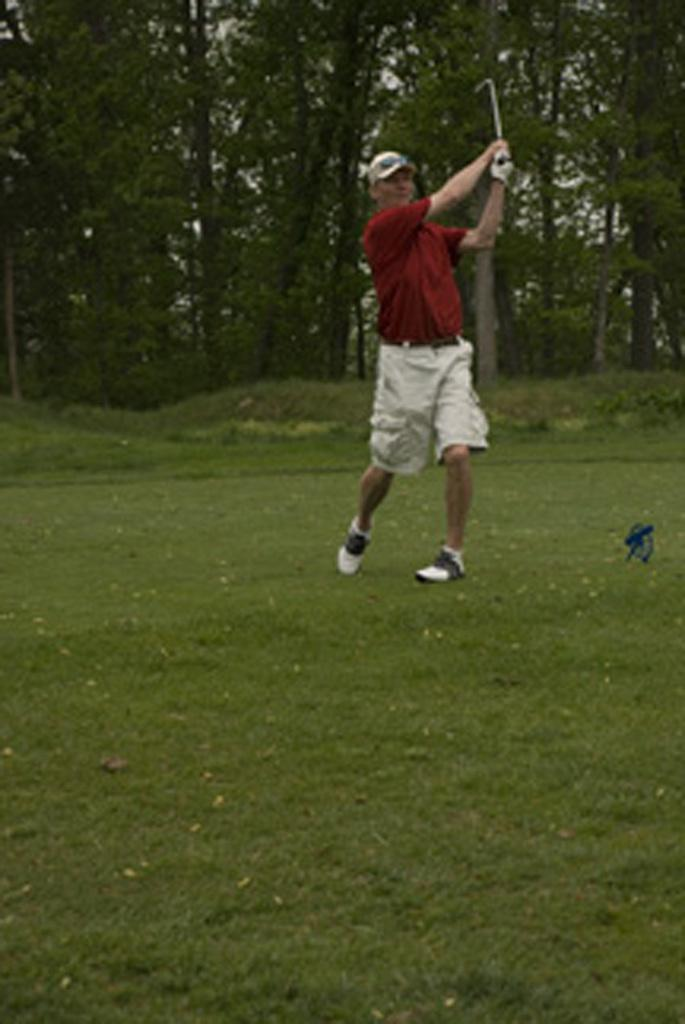What is present in the image? There is a person in the image. What is the person holding? The person is holding an object. What can be seen beneath the person's feet? The ground is visible in the image. What type of vegetation is on the ground? There is grass on the ground. What else can be seen in the image besides the person and the ground? There are trees in the image. What type of apparatus is the person using to measure the height of the trees? There is no apparatus visible in the image for measuring the height of the trees. What type of spoon is the person using to eat the grass? There is no spoon present in the image, and the person is not eating the grass. 